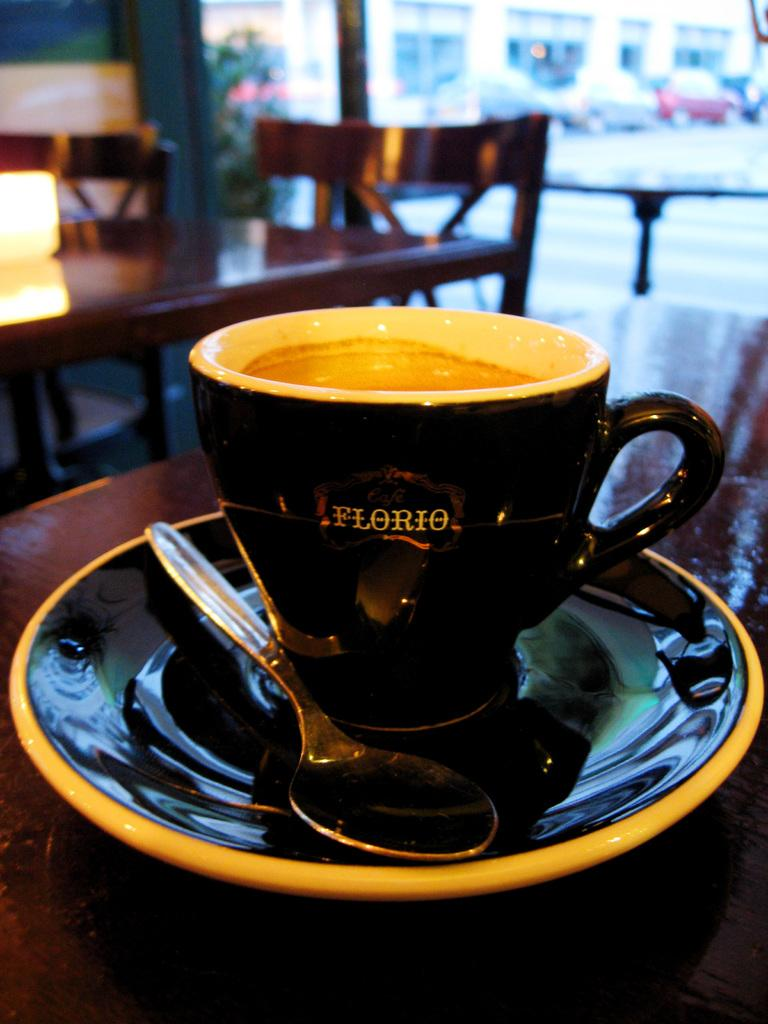What color is the cup in the image? The cup in the image is black. What is the cup placed on? The cup is on a black color saucer. Can you describe the utensil in the image? There is a spoon in the image, and it is on a table. What can be seen in the background of the image? In the background of the image, there are chairs, a car, a building, a plant, and a light. What type of tin can be seen in the image? There is no tin present in the image. How does the cub interact with the plant in the image? There is no cub present in the image, and therefore no interaction with the plant can be observed. 